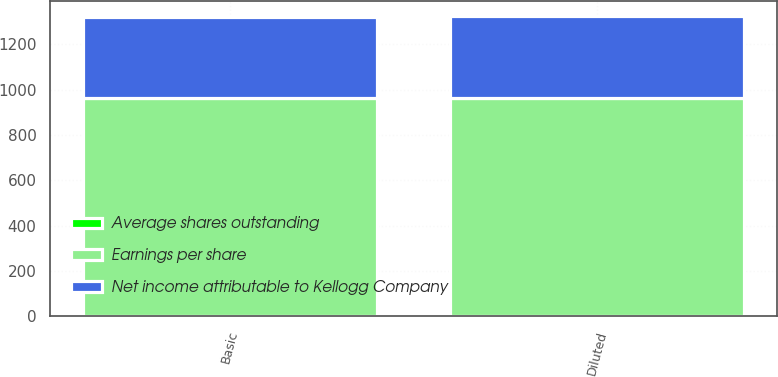Convert chart. <chart><loc_0><loc_0><loc_500><loc_500><stacked_bar_chart><ecel><fcel>Basic<fcel>Diluted<nl><fcel>Earnings per share<fcel>961<fcel>961<nl><fcel>Net income attributable to Kellogg Company<fcel>358<fcel>360<nl><fcel>Average shares outstanding<fcel>2.68<fcel>2.67<nl></chart> 